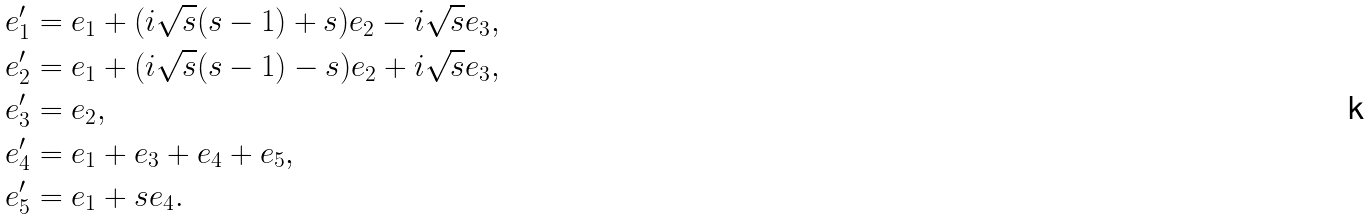<formula> <loc_0><loc_0><loc_500><loc_500>& e ^ { \prime } _ { 1 } = e _ { 1 } + ( i \sqrt { s } ( s - 1 ) + s ) e _ { 2 } - i \sqrt { s } e _ { 3 } , \\ & e ^ { \prime } _ { 2 } = e _ { 1 } + ( i \sqrt { s } ( s - 1 ) - s ) e _ { 2 } + i \sqrt { s } e _ { 3 } , \\ & e ^ { \prime } _ { 3 } = e _ { 2 } , \\ & e ^ { \prime } _ { 4 } = e _ { 1 } + e _ { 3 } + e _ { 4 } + e _ { 5 } , \\ & e ^ { \prime } _ { 5 } = e _ { 1 } + s e _ { 4 } .</formula> 